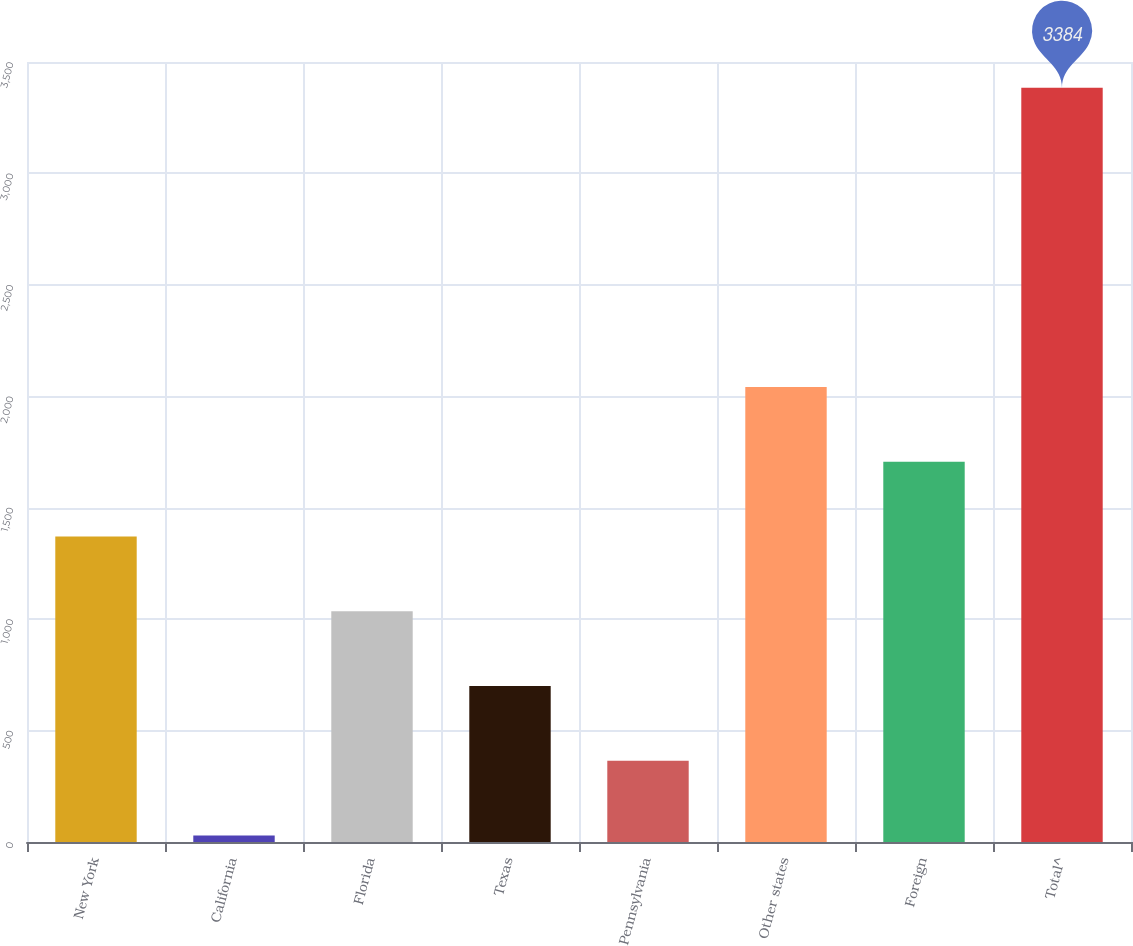<chart> <loc_0><loc_0><loc_500><loc_500><bar_chart><fcel>New York<fcel>California<fcel>Florida<fcel>Texas<fcel>Pennsylvania<fcel>Other states<fcel>Foreign<fcel>Total^<nl><fcel>1371<fcel>29<fcel>1035.5<fcel>700<fcel>364.5<fcel>2042<fcel>1706.5<fcel>3384<nl></chart> 